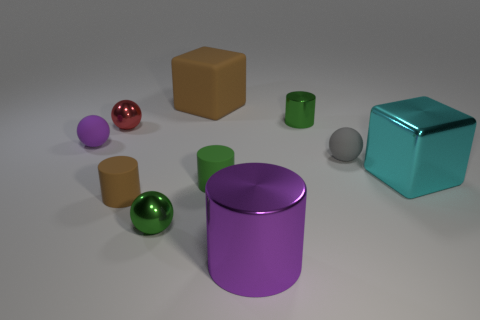The green matte object that is the same shape as the tiny brown rubber thing is what size?
Your answer should be compact. Small. What number of big objects are either cyan shiny cubes or gray metal blocks?
Your response must be concise. 1. Is the purple thing on the right side of the large brown object made of the same material as the cyan cube in front of the red object?
Offer a very short reply. Yes. There is a block behind the small purple object; what material is it?
Your answer should be very brief. Rubber. What number of metal things are either small yellow things or small brown cylinders?
Make the answer very short. 0. The block that is to the left of the cylinder behind the small green rubber object is what color?
Your response must be concise. Brown. Is the material of the purple cylinder the same as the cube right of the small green metal cylinder?
Your answer should be very brief. Yes. There is a cylinder in front of the cylinder on the left side of the tiny shiny thing that is in front of the cyan object; what is its color?
Your answer should be compact. Purple. Is the number of cyan shiny spheres greater than the number of large metallic objects?
Your answer should be very brief. No. What number of big things are both to the right of the purple cylinder and behind the tiny purple rubber sphere?
Offer a terse response. 0. 